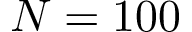Convert formula to latex. <formula><loc_0><loc_0><loc_500><loc_500>N = 1 0 0</formula> 